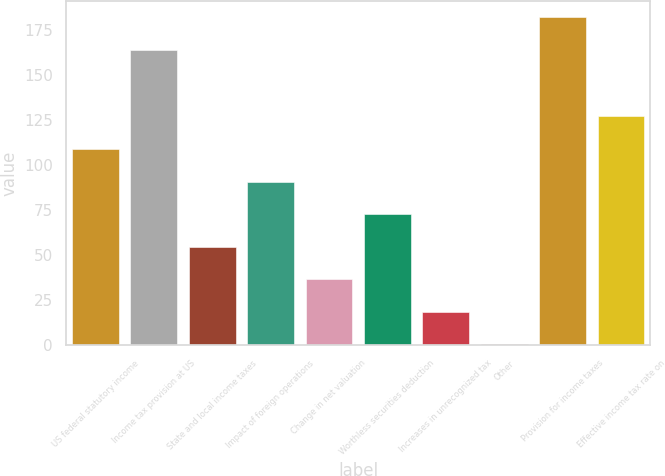Convert chart to OTSL. <chart><loc_0><loc_0><loc_500><loc_500><bar_chart><fcel>US federal statutory income<fcel>Income tax provision at US<fcel>State and local income taxes<fcel>Impact of foreign operations<fcel>Change in net valuation<fcel>Worthless securities deduction<fcel>Increases in unrecognized tax<fcel>Other<fcel>Provision for income taxes<fcel>Effective income tax rate on<nl><fcel>108.96<fcel>163.8<fcel>54.78<fcel>90.9<fcel>36.72<fcel>72.84<fcel>18.66<fcel>0.6<fcel>181.86<fcel>127.02<nl></chart> 